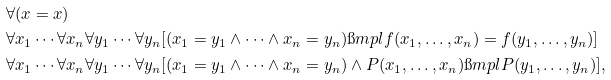Convert formula to latex. <formula><loc_0><loc_0><loc_500><loc_500>& \forall ( x = x ) \\ & \forall x _ { 1 } \cdots \forall x _ { n } \forall y _ { 1 } \cdots \forall y _ { n } [ ( x _ { 1 } = y _ { 1 } \land \cdots \land x _ { n } = y _ { n } ) \i m p l f ( x _ { 1 } , \dots , x _ { n } ) = f ( y _ { 1 } , \dots , y _ { n } ) ] \\ & \forall x _ { 1 } \cdots \forall x _ { n } \forall y _ { 1 } \cdots \forall y _ { n } [ ( x _ { 1 } = y _ { 1 } \land \cdots \land x _ { n } = y _ { n } ) \land P ( x _ { 1 } , \dots , x _ { n } ) \i m p l P ( y _ { 1 } , \dots , y _ { n } ) ] ,</formula> 